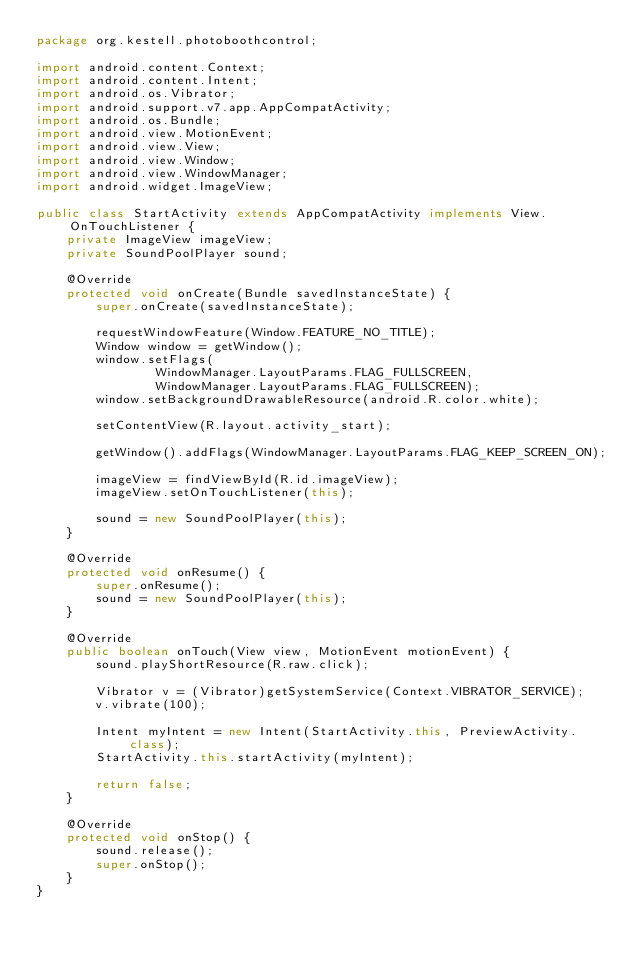Convert code to text. <code><loc_0><loc_0><loc_500><loc_500><_Java_>package org.kestell.photoboothcontrol;

import android.content.Context;
import android.content.Intent;
import android.os.Vibrator;
import android.support.v7.app.AppCompatActivity;
import android.os.Bundle;
import android.view.MotionEvent;
import android.view.View;
import android.view.Window;
import android.view.WindowManager;
import android.widget.ImageView;

public class StartActivity extends AppCompatActivity implements View.OnTouchListener {
    private ImageView imageView;
    private SoundPoolPlayer sound;

    @Override
    protected void onCreate(Bundle savedInstanceState) {
        super.onCreate(savedInstanceState);

        requestWindowFeature(Window.FEATURE_NO_TITLE);
        Window window = getWindow();
        window.setFlags(
                WindowManager.LayoutParams.FLAG_FULLSCREEN,
                WindowManager.LayoutParams.FLAG_FULLSCREEN);
        window.setBackgroundDrawableResource(android.R.color.white);

        setContentView(R.layout.activity_start);

        getWindow().addFlags(WindowManager.LayoutParams.FLAG_KEEP_SCREEN_ON);

        imageView = findViewById(R.id.imageView);
        imageView.setOnTouchListener(this);

        sound = new SoundPoolPlayer(this);
    }

    @Override
    protected void onResume() {
        super.onResume();
        sound = new SoundPoolPlayer(this);
    }

    @Override
    public boolean onTouch(View view, MotionEvent motionEvent) {
        sound.playShortResource(R.raw.click);

        Vibrator v = (Vibrator)getSystemService(Context.VIBRATOR_SERVICE);
        v.vibrate(100);

        Intent myIntent = new Intent(StartActivity.this, PreviewActivity.class);
        StartActivity.this.startActivity(myIntent);

        return false;
    }

    @Override
    protected void onStop() {
        sound.release();
        super.onStop();
    }
}
</code> 